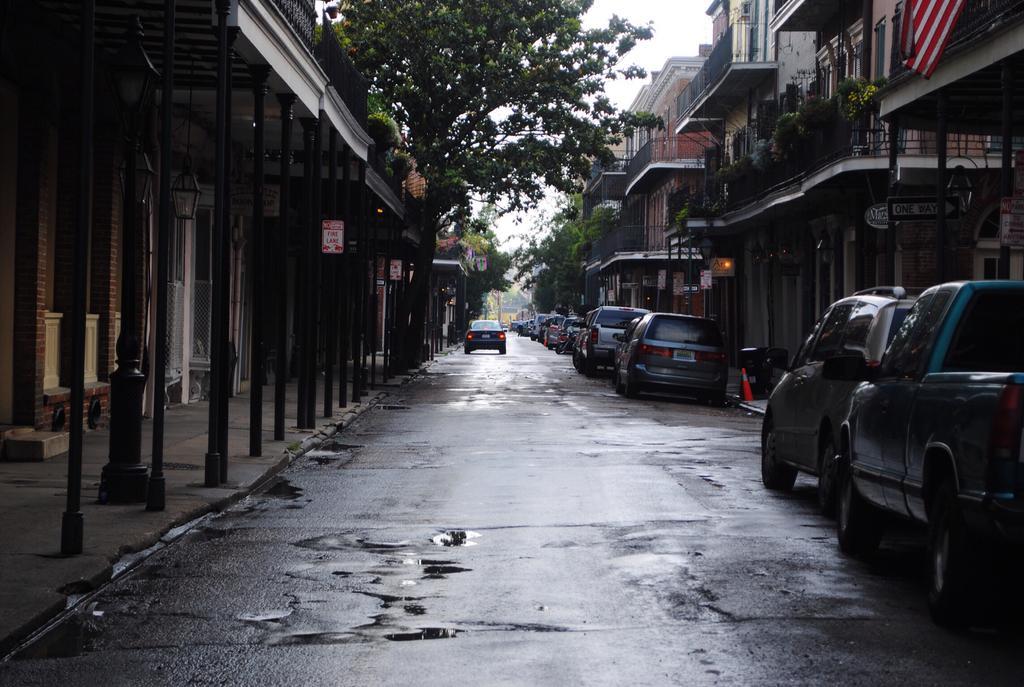How would you summarize this image in a sentence or two? In this image we can see a group of buildings with windows, pillars, roof, a fence, railing and a street lamp. We can also see a signboard, a traffic pole and a group of cars parked aside on the road. On the backside we can see a divider pole, a group of trees, plants and the sky. 